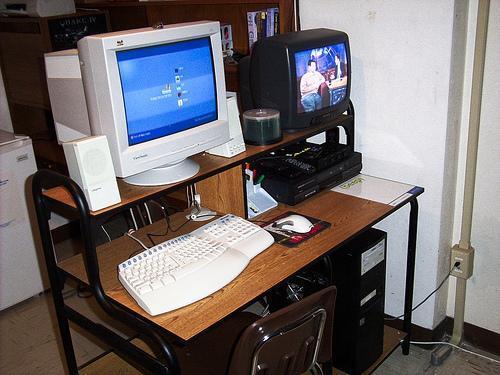How many tvs are in the picture?
Give a very brief answer. 2. How many chairs are there?
Give a very brief answer. 2. 